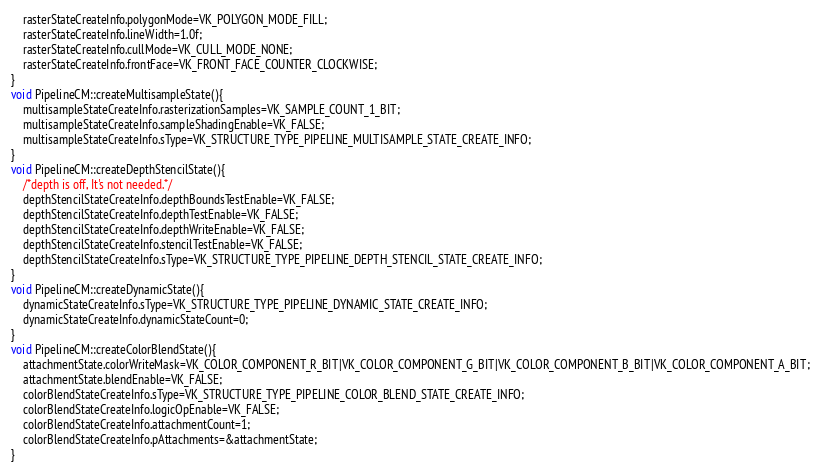Convert code to text. <code><loc_0><loc_0><loc_500><loc_500><_C++_>    rasterStateCreateInfo.polygonMode=VK_POLYGON_MODE_FILL;
    rasterStateCreateInfo.lineWidth=1.0f;
    rasterStateCreateInfo.cullMode=VK_CULL_MODE_NONE;
    rasterStateCreateInfo.frontFace=VK_FRONT_FACE_COUNTER_CLOCKWISE;
}
void PipelineCM::createMultisampleState(){
    multisampleStateCreateInfo.rasterizationSamples=VK_SAMPLE_COUNT_1_BIT;
    multisampleStateCreateInfo.sampleShadingEnable=VK_FALSE;
    multisampleStateCreateInfo.sType=VK_STRUCTURE_TYPE_PIPELINE_MULTISAMPLE_STATE_CREATE_INFO;
}
void PipelineCM::createDepthStencilState(){
    /*depth is off, It's not needed.*/
    depthStencilStateCreateInfo.depthBoundsTestEnable=VK_FALSE;
    depthStencilStateCreateInfo.depthTestEnable=VK_FALSE;
    depthStencilStateCreateInfo.depthWriteEnable=VK_FALSE;
    depthStencilStateCreateInfo.stencilTestEnable=VK_FALSE;
    depthStencilStateCreateInfo.sType=VK_STRUCTURE_TYPE_PIPELINE_DEPTH_STENCIL_STATE_CREATE_INFO;
}
void PipelineCM::createDynamicState(){
    dynamicStateCreateInfo.sType=VK_STRUCTURE_TYPE_PIPELINE_DYNAMIC_STATE_CREATE_INFO;
    dynamicStateCreateInfo.dynamicStateCount=0;
}
void PipelineCM::createColorBlendState(){
    attachmentState.colorWriteMask=VK_COLOR_COMPONENT_R_BIT|VK_COLOR_COMPONENT_G_BIT|VK_COLOR_COMPONENT_B_BIT|VK_COLOR_COMPONENT_A_BIT;
    attachmentState.blendEnable=VK_FALSE;
    colorBlendStateCreateInfo.sType=VK_STRUCTURE_TYPE_PIPELINE_COLOR_BLEND_STATE_CREATE_INFO;
    colorBlendStateCreateInfo.logicOpEnable=VK_FALSE;
    colorBlendStateCreateInfo.attachmentCount=1;
    colorBlendStateCreateInfo.pAttachments=&attachmentState;
}</code> 